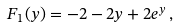<formula> <loc_0><loc_0><loc_500><loc_500>F _ { 1 } ( y ) = - 2 - 2 y + 2 e ^ { y } \, ,</formula> 